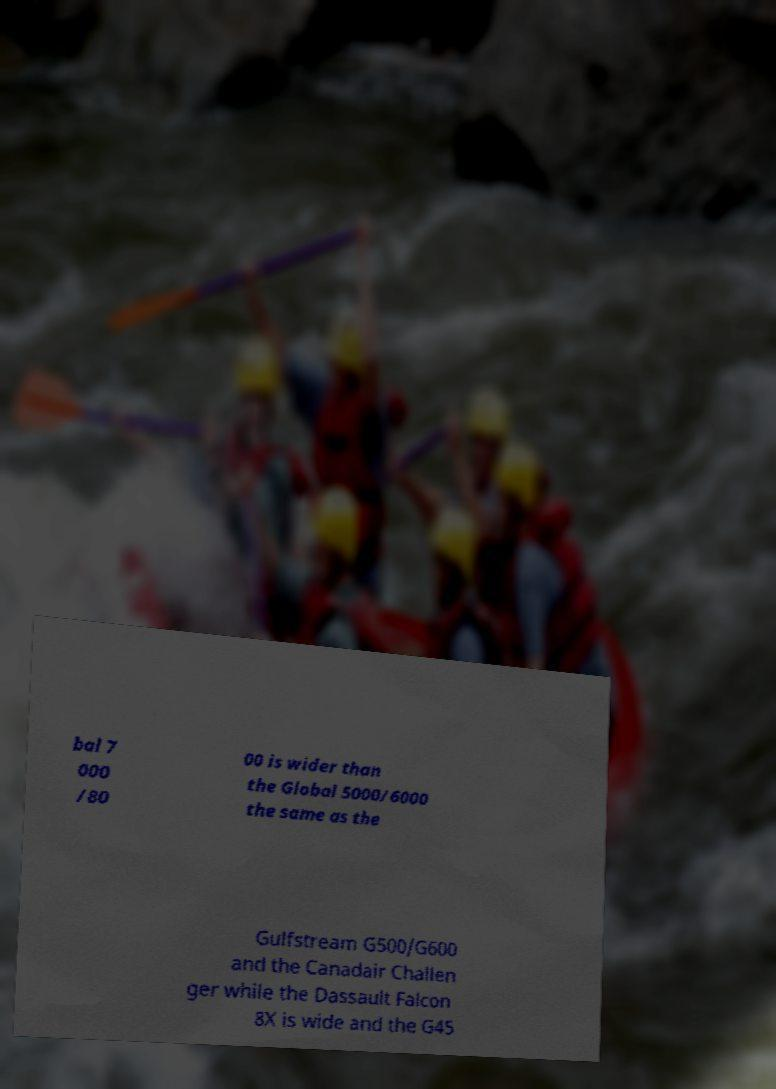I need the written content from this picture converted into text. Can you do that? bal 7 000 /80 00 is wider than the Global 5000/6000 the same as the Gulfstream G500/G600 and the Canadair Challen ger while the Dassault Falcon 8X is wide and the G45 